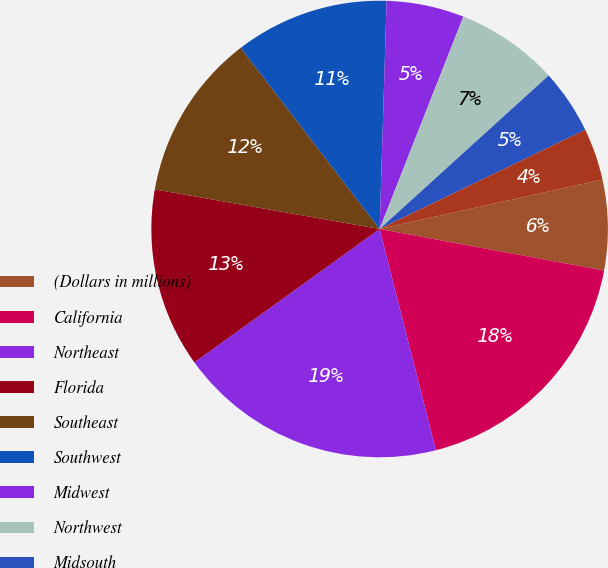Convert chart to OTSL. <chart><loc_0><loc_0><loc_500><loc_500><pie_chart><fcel>(Dollars in millions)<fcel>California<fcel>Northeast<fcel>Florida<fcel>Southeast<fcel>Southwest<fcel>Midwest<fcel>Northwest<fcel>Midsouth<fcel>Other<nl><fcel>6.39%<fcel>18.12%<fcel>19.03%<fcel>12.71%<fcel>11.81%<fcel>10.9%<fcel>5.49%<fcel>7.29%<fcel>4.58%<fcel>3.68%<nl></chart> 